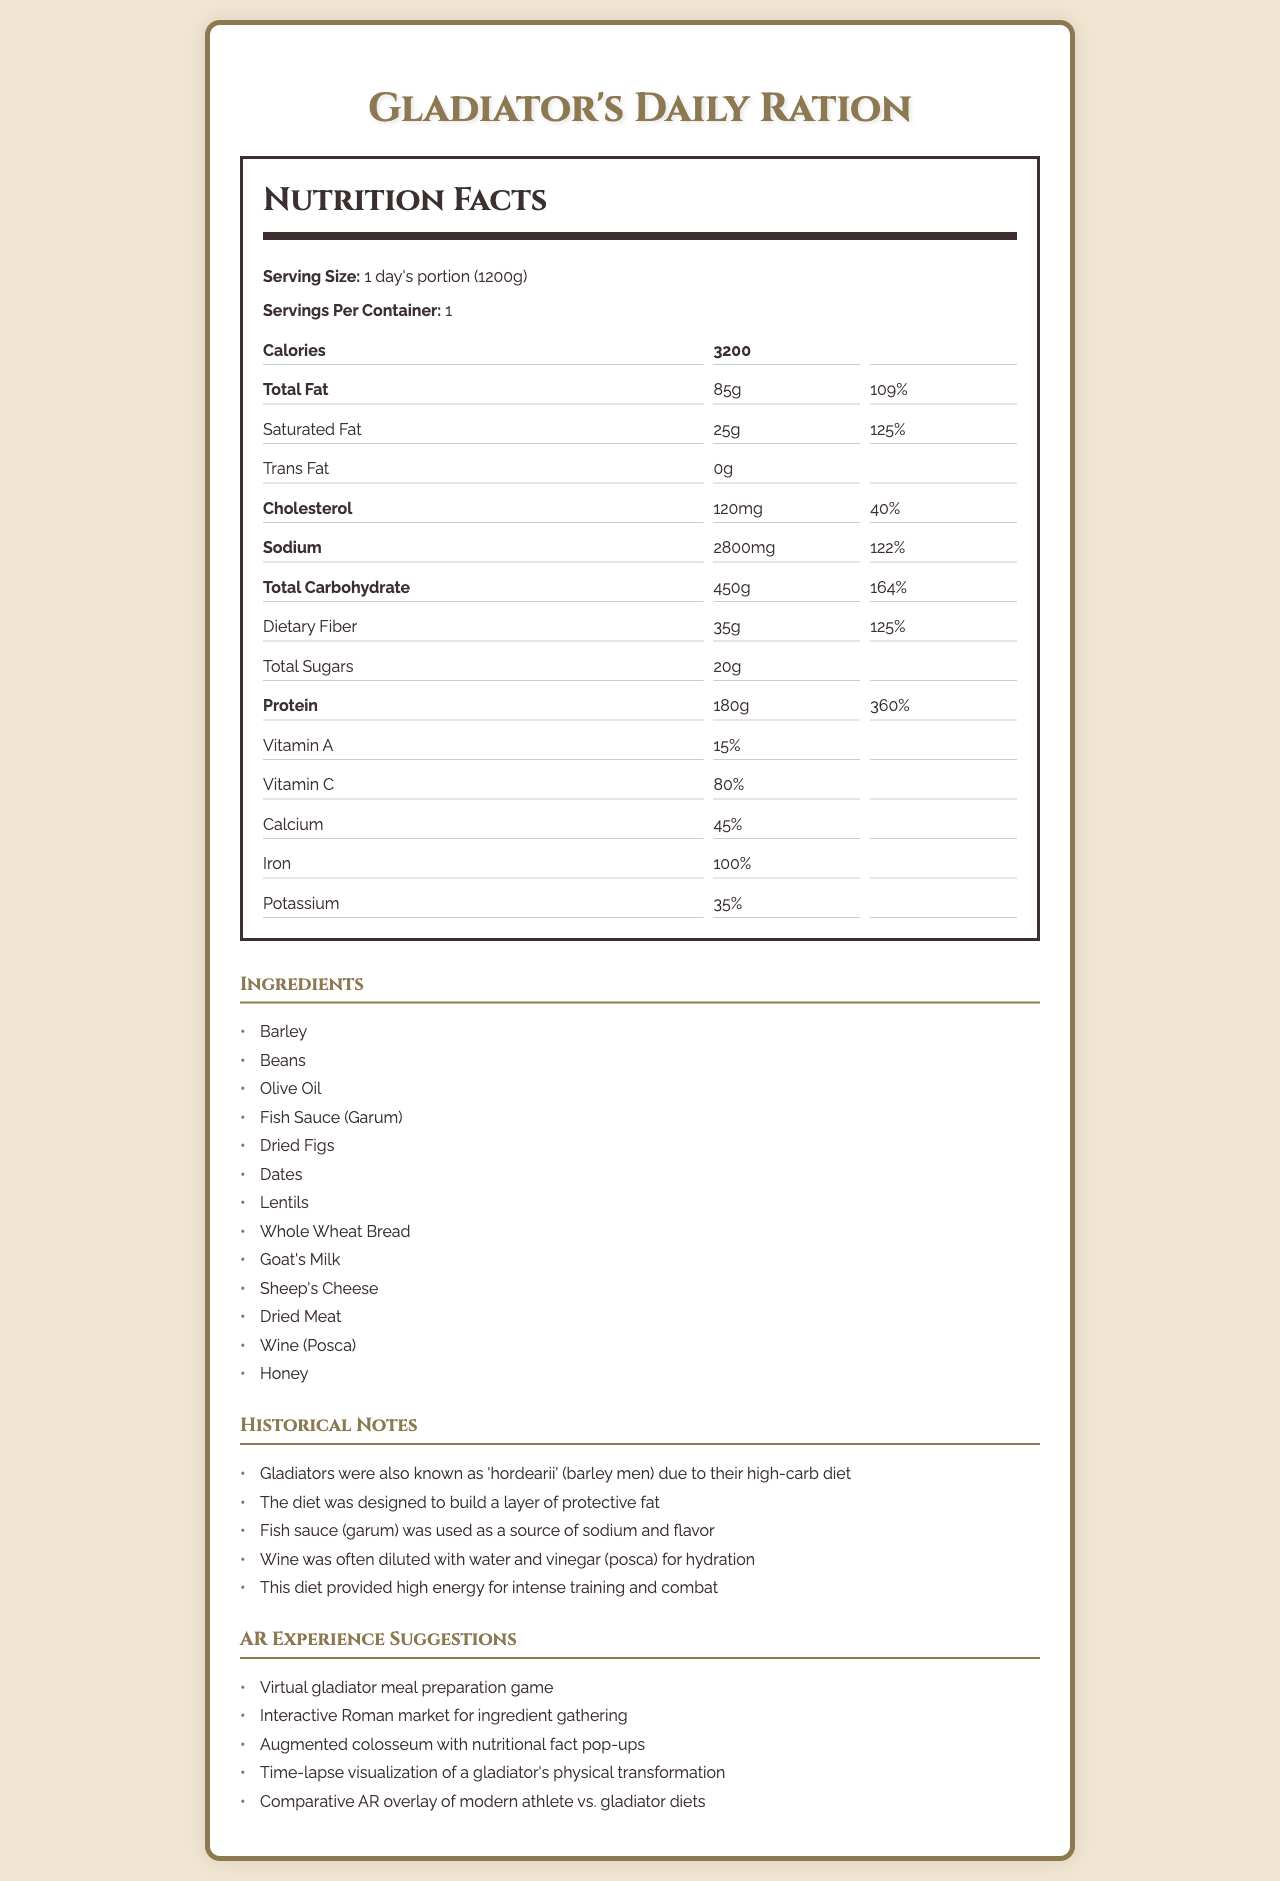when looking at the document, what is the serving size for Gladiator's Daily Ration? The serving size is displayed near the top of the nutrition label.
Answer: 1 day's portion (1200g) how many calories does a gladiator consume in a day based on the label? The number of calories is listed prominently in the nutrition facts section.
Answer: 3200 what is the total amount of fat a gladiator consumes per day, and what percentage of the daily value does it represent? The document states "Total Fat" as 85g and "Daily Value" as 109%.
Answer: 85g (109%) which ingredient provides the main source of sodium in the gladiator's diet? The historical notes mention that fish sauce (garum) was used as a source of sodium.
Answer: Fish Sauce (Garum) what are the top three ingredients listed in the Gladiator's Daily Ration? The ingredients section lists these as the first three items.
Answer: Barley, Beans, Olive Oil how much protein does a gladiator consume per day, and what percentage of the daily value does it represent? The document specifies "Protein" as 180g and "Daily Value" as 360%.
Answer: 180g (360%) what is the percentage of iron provided by the gladiator diet? The nutrition facts section lists iron with a daily value of 100%.
Answer: 100% how many grams of fiber are in a day's portion of the Gladiator's Daily Ration? The nutrition label indicates dietary fiber amounts to 35g.
Answer: 35g what is one key reason gladiators consumed a high-carb diet? A. To improve mental alertness B. To build muscle C. To build a layer of protective fat D. To reduce training time The historical notes mention that the diet was designed to build a layer of protective fat.
Answer: C which of the following was commonly used as hydration for gladiators? I. Wine (Posca) II. Beer III. Plain Water The historical notes specify that wine (posca) was often diluted with water and vinegar for hydration.
Answer: I can we determine the specific amount of each vitamin (A, C, Calcium, Iron, Potassium) from the document? Only the percentages of daily values for Vitamin A, Vitamin C, Calcium, Iron, and Potassium are provided; the specific amounts are not listed.
Answer: No is dried meat part of the gladiator's diet according to the nutrition facts label? The ingredients section lists dried meat as one of the components.
Answer: Yes summarize the main content and purpose of this document. The explanation includes the key elements of the document, such as the product name, serving size, nutritional information, historical context, and AR experience suggestions, offering an overview of the content and its purpose.
Answer: The document provides a detailed nutrition facts label for an ancient Roman gladiator's daily diet, listing ingredients, nutritional content, historical notes on the diet's purpose, and suggestions for augmented reality (AR) experiences related to this diet. The diet is high in calories, protein, carbohydrates, sodium, and fat, and includes historically accurate ingredients such as barley, beans, fish sauce, and wine. what is the purpose of including augmented reality (AR) experience suggestions in the document? The AR experience suggestions offer a range of possibilities from meal preparation games to visual overlays, enhancing engagement with the historical content.
Answer: To provide ideas for interactive and immersive ways to explore and present the historical content of the gladiator's diet. do gladiators' diets have higher carbohydrate or protein percentages in their daily value according to the document? The daily value percentage for protein is significantly higher than that for total carbohydrate (164%).
Answer: Protein (360%) 